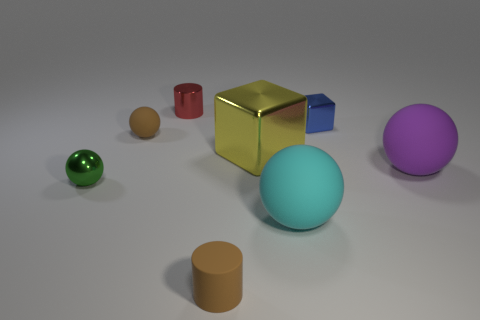How many other things are there of the same material as the green sphere?
Give a very brief answer. 3. Does the small brown sphere have the same material as the cylinder that is in front of the big purple sphere?
Provide a short and direct response. Yes. Is the number of green spheres on the left side of the small red metallic thing less than the number of cubes left of the green object?
Ensure brevity in your answer.  No. There is a small matte object behind the cyan matte thing; what color is it?
Make the answer very short. Brown. What number of other things are there of the same color as the tiny shiny cube?
Keep it short and to the point. 0. There is a cylinder that is behind the blue metal block; is it the same size as the small green shiny thing?
Ensure brevity in your answer.  Yes. Are there the same number of small yellow shiny blocks and tiny metal cylinders?
Give a very brief answer. No. There is a yellow object; how many balls are left of it?
Offer a very short reply. 2. Is there a yellow metallic object that has the same size as the green metallic thing?
Keep it short and to the point. No. Do the big metal object and the small rubber sphere have the same color?
Provide a succinct answer. No. 